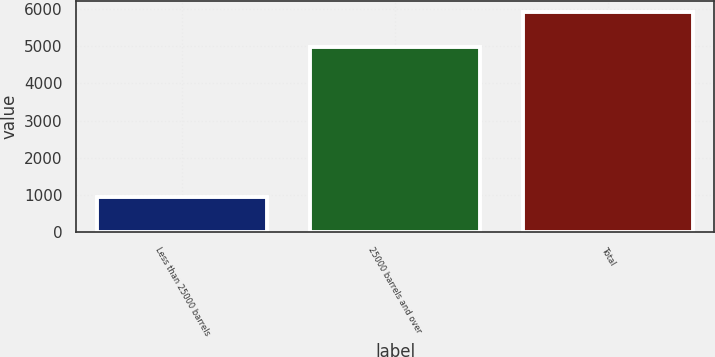Convert chart to OTSL. <chart><loc_0><loc_0><loc_500><loc_500><bar_chart><fcel>Less than 25000 barrels<fcel>25000 barrels and over<fcel>Total<nl><fcel>942<fcel>4985<fcel>5927<nl></chart> 